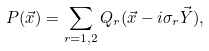<formula> <loc_0><loc_0><loc_500><loc_500>P ( \vec { x } ) = \sum _ { r = 1 , 2 } Q _ { r } ( \vec { x } - i \sigma _ { r } \vec { Y } ) ,</formula> 